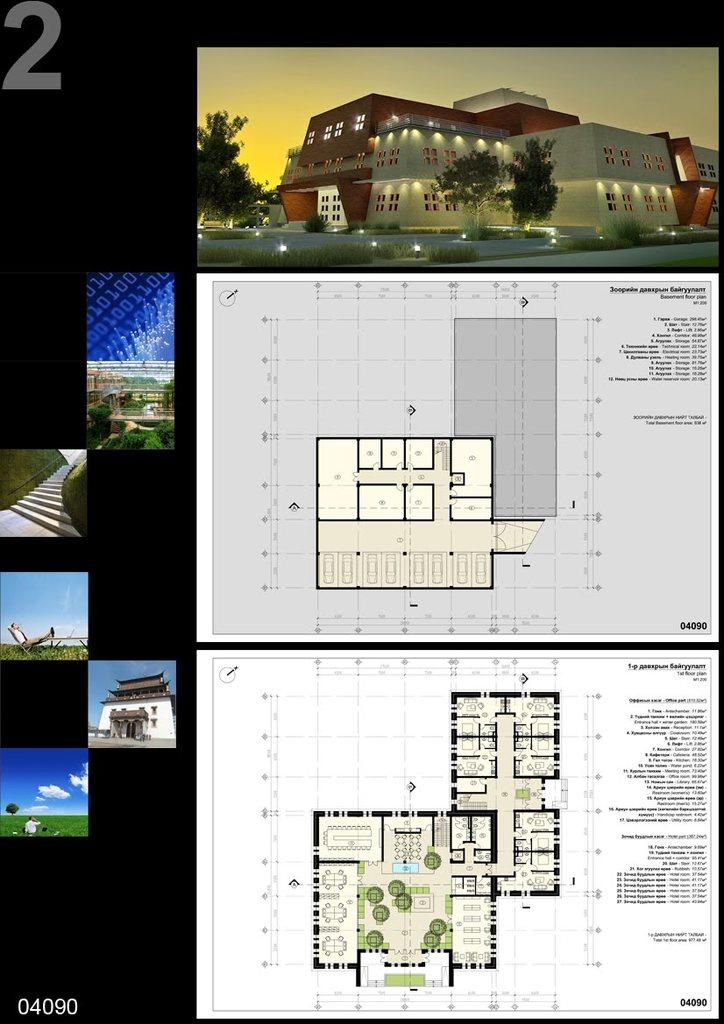What is the format of the image? The image is a collage of multiple images. What type of subject matter is featured in the collage? There are images of buildings in the collage. How many different layouts of a building are depicted in the collage? There are two layouts of a building depicted in the collage. What can be seen in the sky in some images of the collage? There are clouds visible in the sky in some images of the collage. What type of drum is being played in the image? There is no drum present in the image; it is a collage of multiple images featuring buildings. 